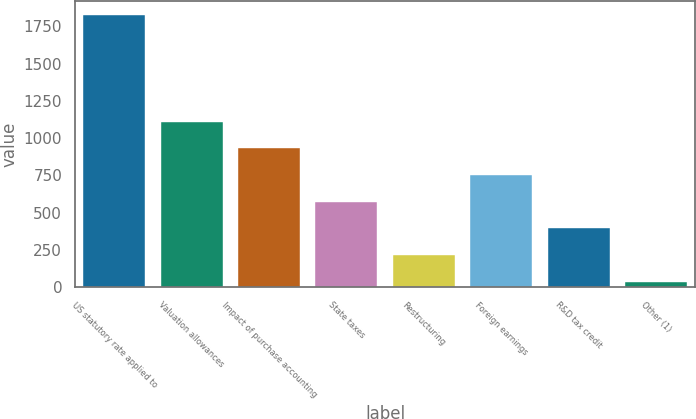<chart> <loc_0><loc_0><loc_500><loc_500><bar_chart><fcel>US statutory rate applied to<fcel>Valuation allowances<fcel>Impact of purchase accounting<fcel>State taxes<fcel>Restructuring<fcel>Foreign earnings<fcel>R&D tax credit<fcel>Other (1)<nl><fcel>1827<fcel>1111.4<fcel>932.5<fcel>574.7<fcel>216.9<fcel>753.6<fcel>395.8<fcel>38<nl></chart> 